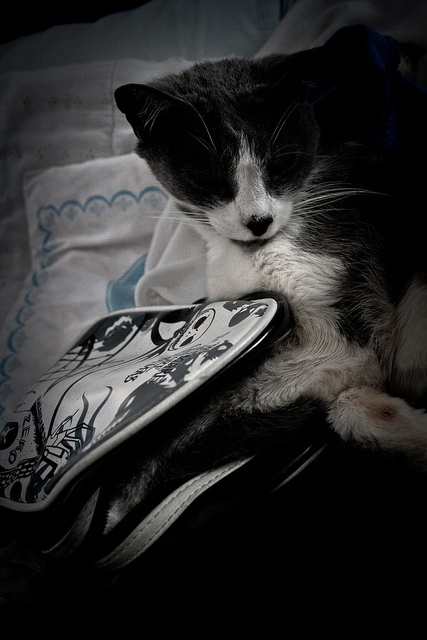Describe the objects in this image and their specific colors. I can see cat in black, gray, and darkgray tones and backpack in black, darkgray, gray, and lightgray tones in this image. 